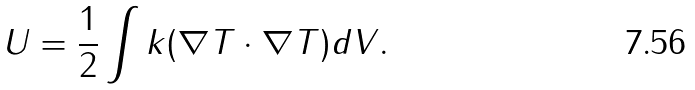<formula> <loc_0><loc_0><loc_500><loc_500>U = \frac { 1 } { 2 } \int k ( \nabla T \cdot \nabla T ) d V .</formula> 